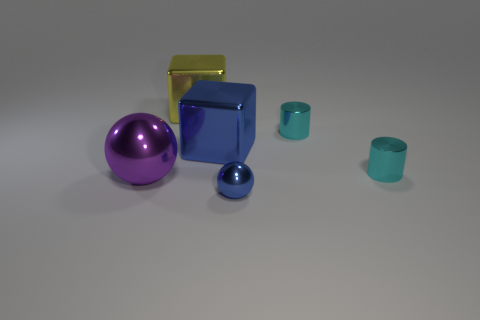Add 3 large spheres. How many objects exist? 9 Subtract all cylinders. How many objects are left? 4 Add 4 big shiny objects. How many big shiny objects exist? 7 Subtract 2 cyan cylinders. How many objects are left? 4 Subtract all large purple shiny spheres. Subtract all small cyan shiny cylinders. How many objects are left? 3 Add 5 tiny cyan shiny cylinders. How many tiny cyan shiny cylinders are left? 7 